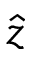Convert formula to latex. <formula><loc_0><loc_0><loc_500><loc_500>\hat { z }</formula> 